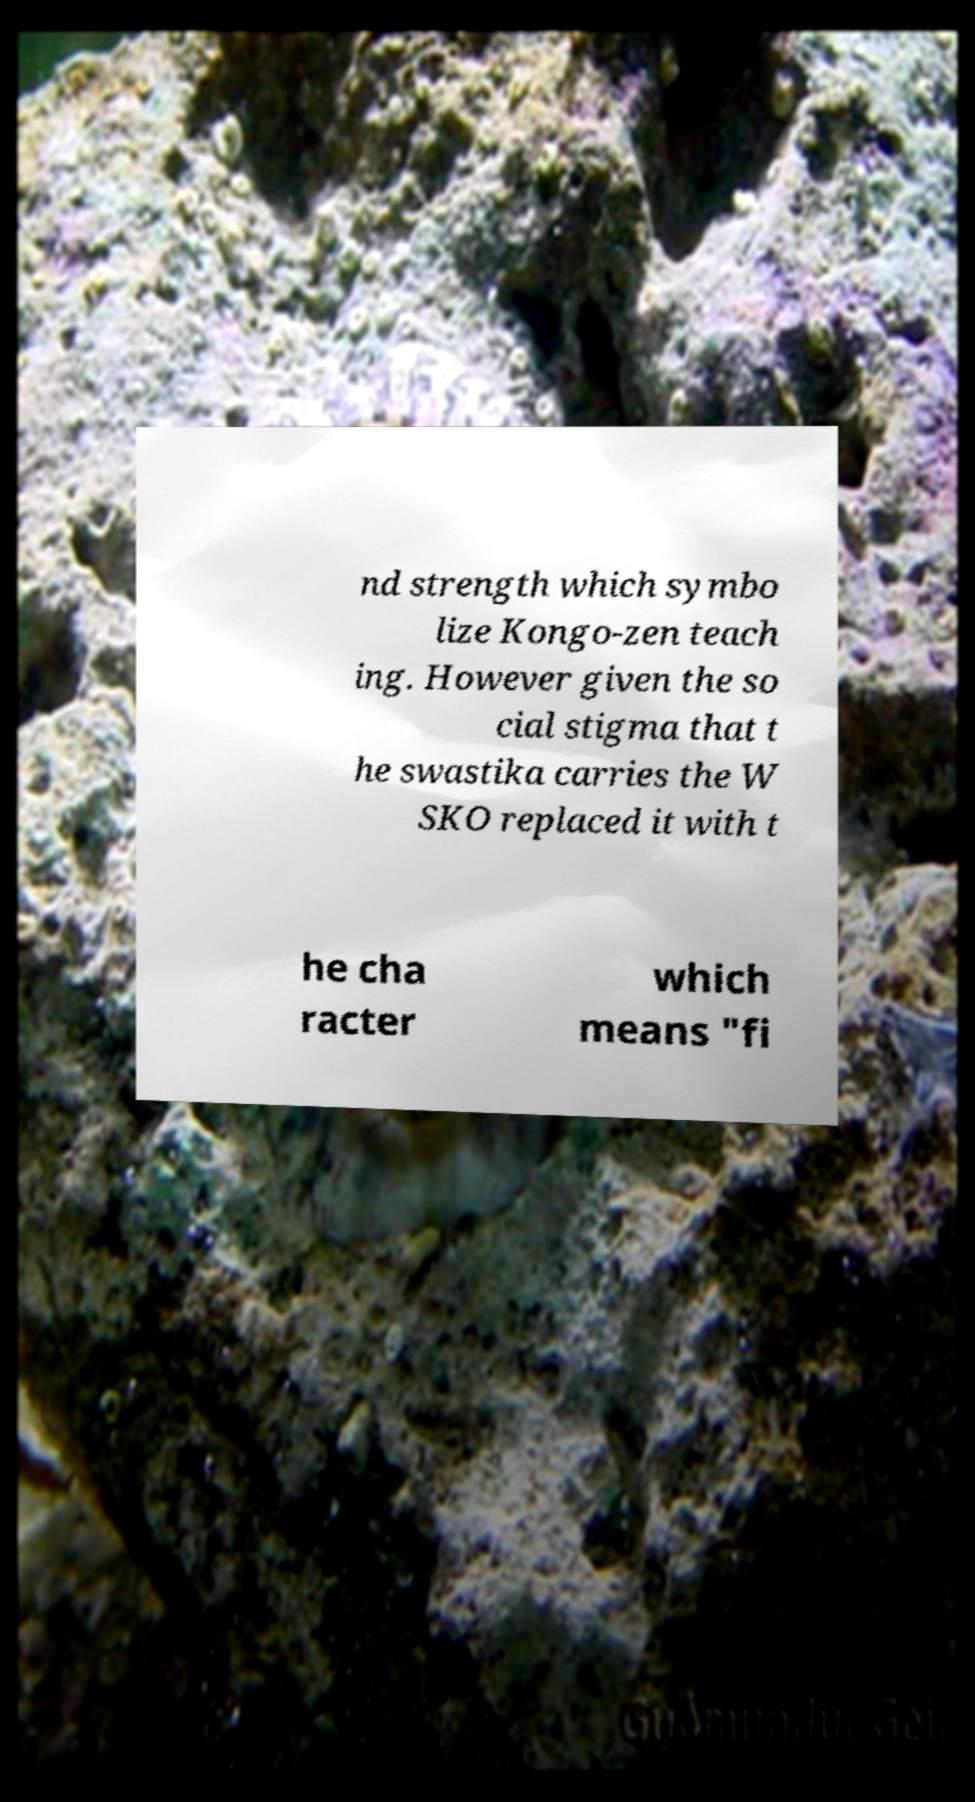Could you assist in decoding the text presented in this image and type it out clearly? nd strength which symbo lize Kongo-zen teach ing. However given the so cial stigma that t he swastika carries the W SKO replaced it with t he cha racter which means "fi 